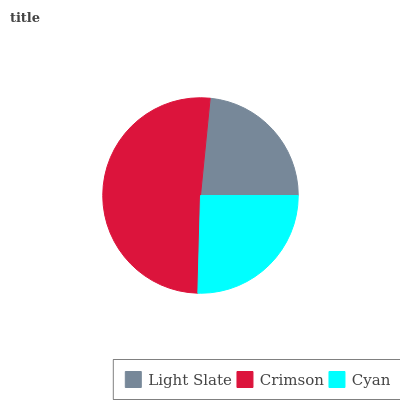Is Light Slate the minimum?
Answer yes or no. Yes. Is Crimson the maximum?
Answer yes or no. Yes. Is Cyan the minimum?
Answer yes or no. No. Is Cyan the maximum?
Answer yes or no. No. Is Crimson greater than Cyan?
Answer yes or no. Yes. Is Cyan less than Crimson?
Answer yes or no. Yes. Is Cyan greater than Crimson?
Answer yes or no. No. Is Crimson less than Cyan?
Answer yes or no. No. Is Cyan the high median?
Answer yes or no. Yes. Is Cyan the low median?
Answer yes or no. Yes. Is Crimson the high median?
Answer yes or no. No. Is Crimson the low median?
Answer yes or no. No. 